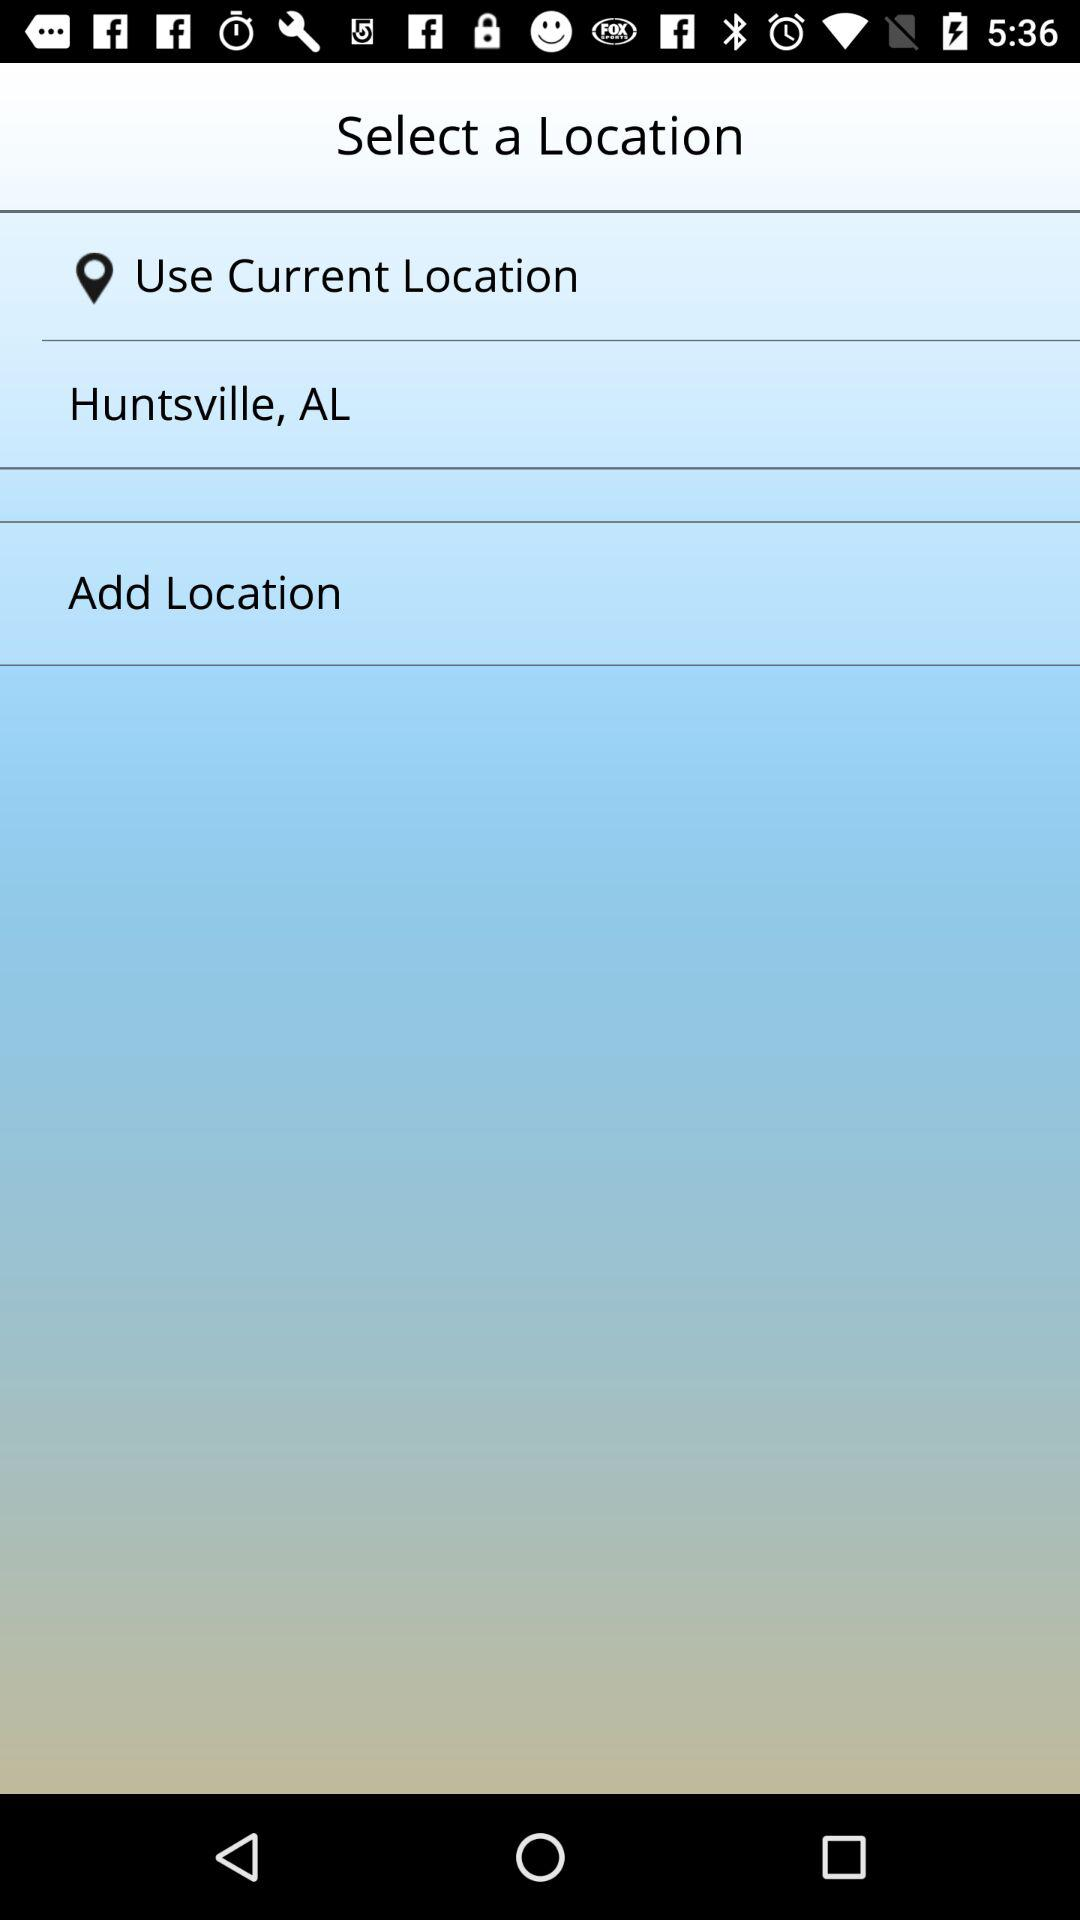How many locations are available to select?
Answer the question using a single word or phrase. 2 